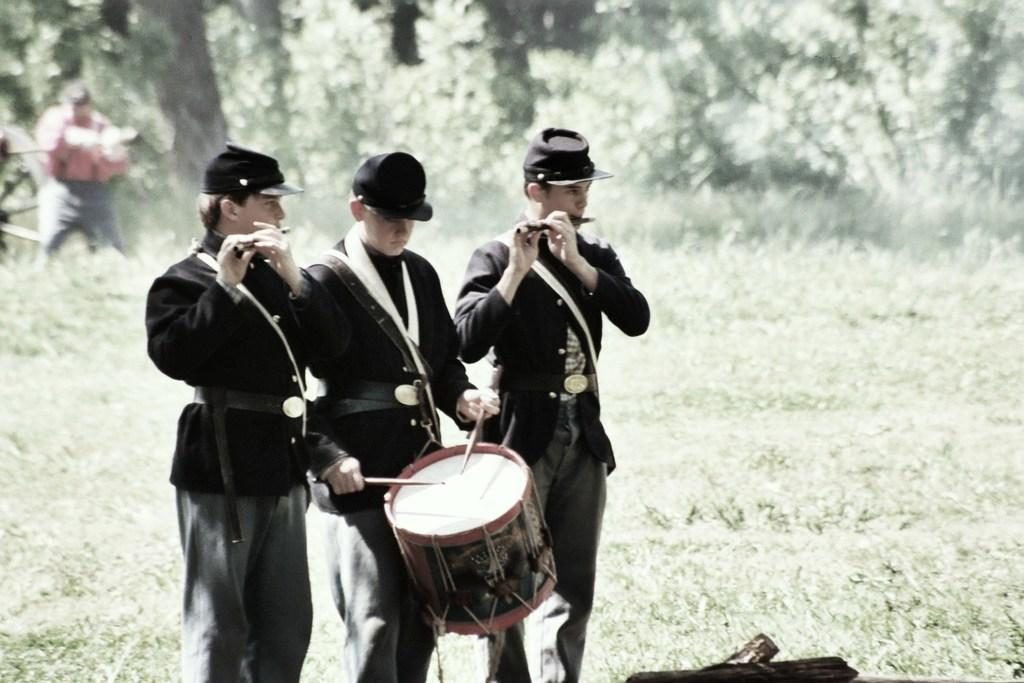How many people are in the image? There are three men in the image. What are the men doing in the image? The men are playing musical instruments. What type of oil can be seen dripping from the orange in the image? There is no orange or oil present in the image; the men are playing musical instruments. How many babies are visible in the image? There are no babies present in the image; it features three men playing musical instruments. 